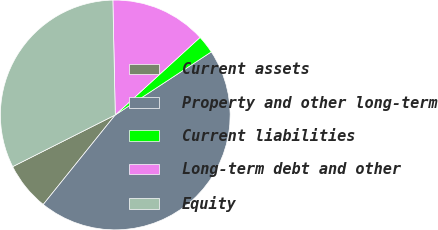<chart> <loc_0><loc_0><loc_500><loc_500><pie_chart><fcel>Current assets<fcel>Property and other long-term<fcel>Current liabilities<fcel>Long-term debt and other<fcel>Equity<nl><fcel>6.79%<fcel>45.03%<fcel>2.54%<fcel>13.54%<fcel>32.09%<nl></chart> 